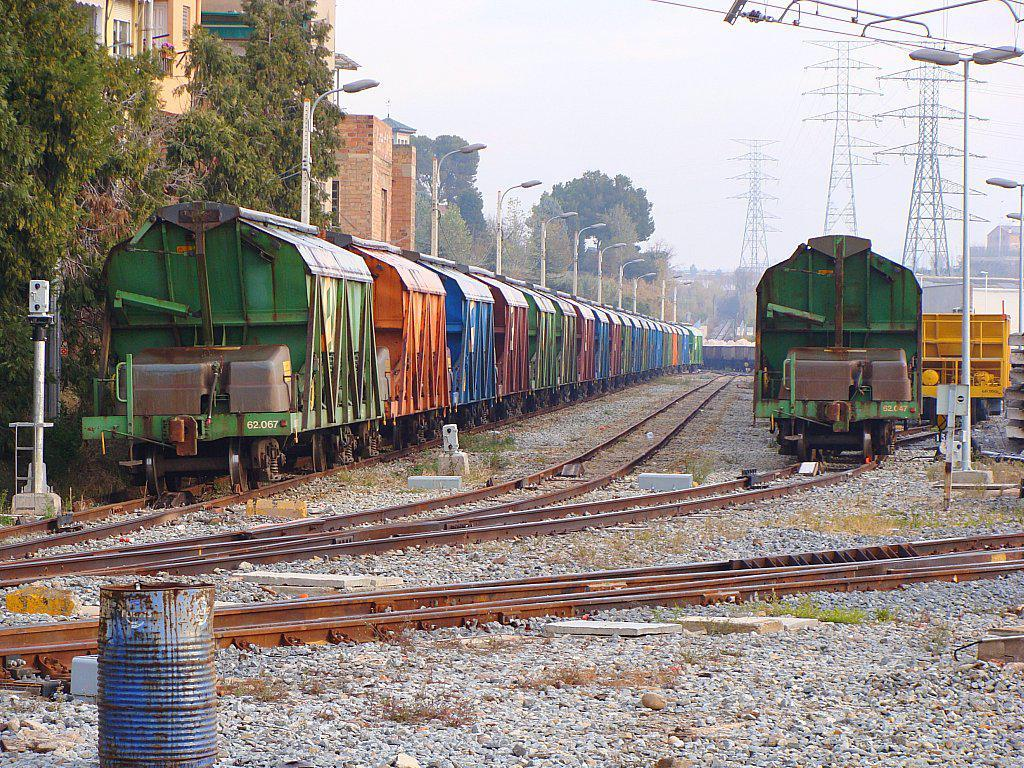What can be seen on the railway tracks in the image? There are trains on the railway tracks in the image. What type of structures can be seen in the background of the image? There are buildings, trees, street lights, and towers in the background of the image. What part of the natural environment is visible in the image? The sky is visible in the background of the image. What type of bait is the stranger using to catch fish in the image? There is no stranger or fishing activity present in the image. What is the plot of the story unfolding in the image? The image does not depict a story or plot; it is a static scene of trains on railway tracks with various background elements. 